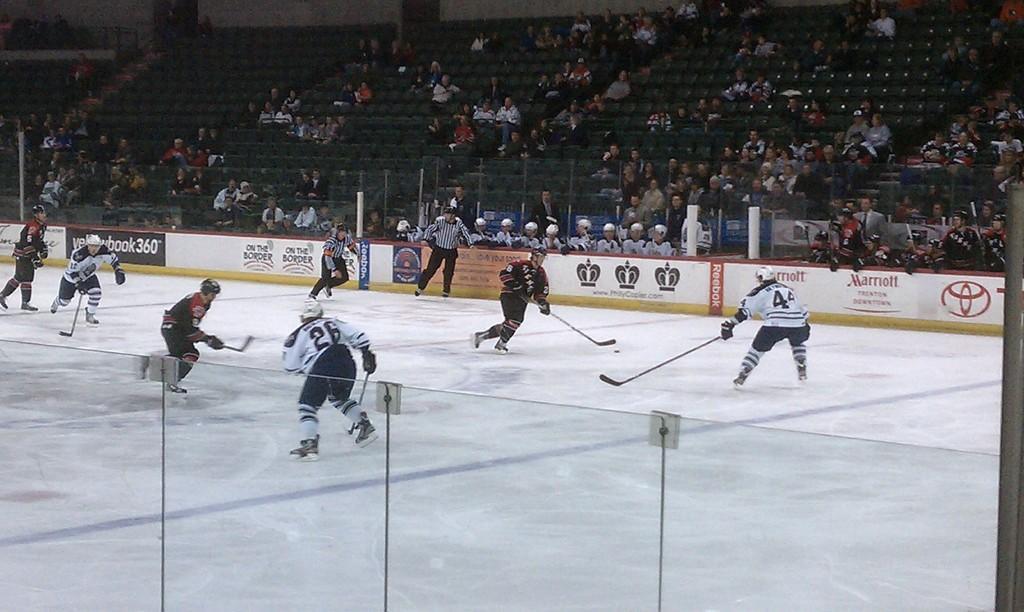Describe this image in one or two sentences. In this image I can see few people are wearing sports dresses, helmets on their heads, holding bats in the hands and playing a game on the floor. At the bottom there is a glass. At the top of the image there are many people sitting on the chairs and looking at the people who are playing. 